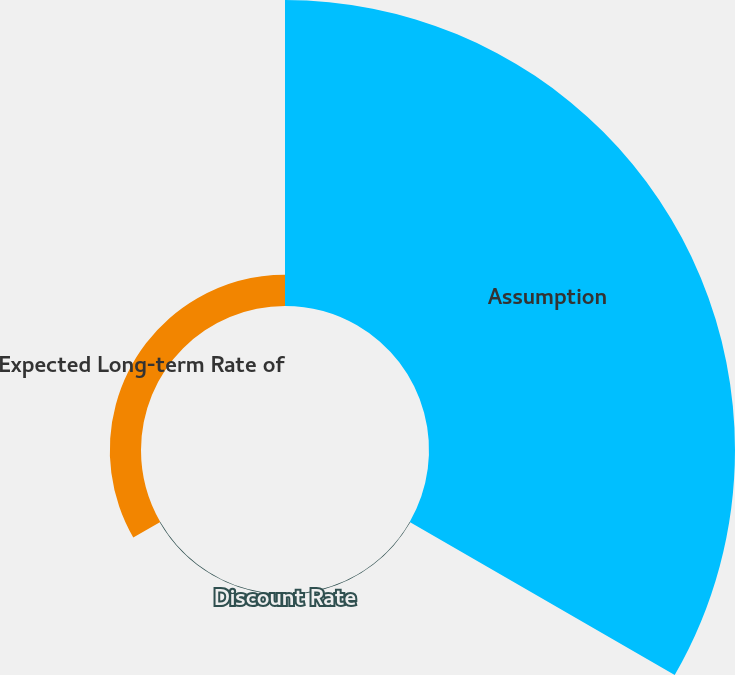<chart> <loc_0><loc_0><loc_500><loc_500><pie_chart><fcel>Assumption<fcel>Discount Rate<fcel>Expected Long-term Rate of<nl><fcel>90.57%<fcel>0.2%<fcel>9.23%<nl></chart> 